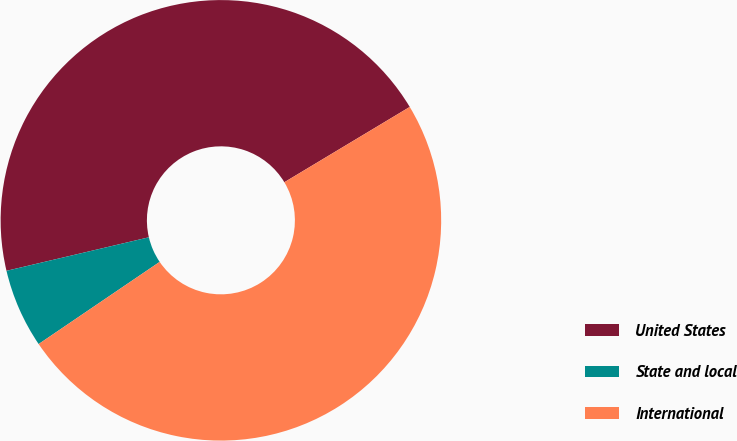Convert chart. <chart><loc_0><loc_0><loc_500><loc_500><pie_chart><fcel>United States<fcel>State and local<fcel>International<nl><fcel>45.07%<fcel>5.81%<fcel>49.11%<nl></chart> 